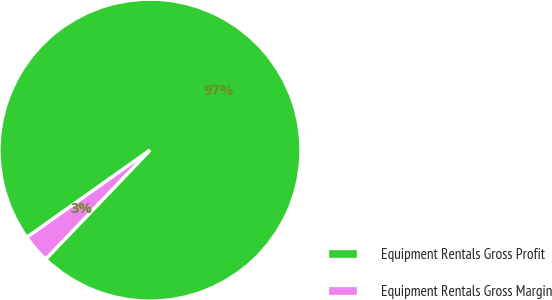Convert chart. <chart><loc_0><loc_0><loc_500><loc_500><pie_chart><fcel>Equipment Rentals Gross Profit<fcel>Equipment Rentals Gross Margin<nl><fcel>96.96%<fcel>3.04%<nl></chart> 